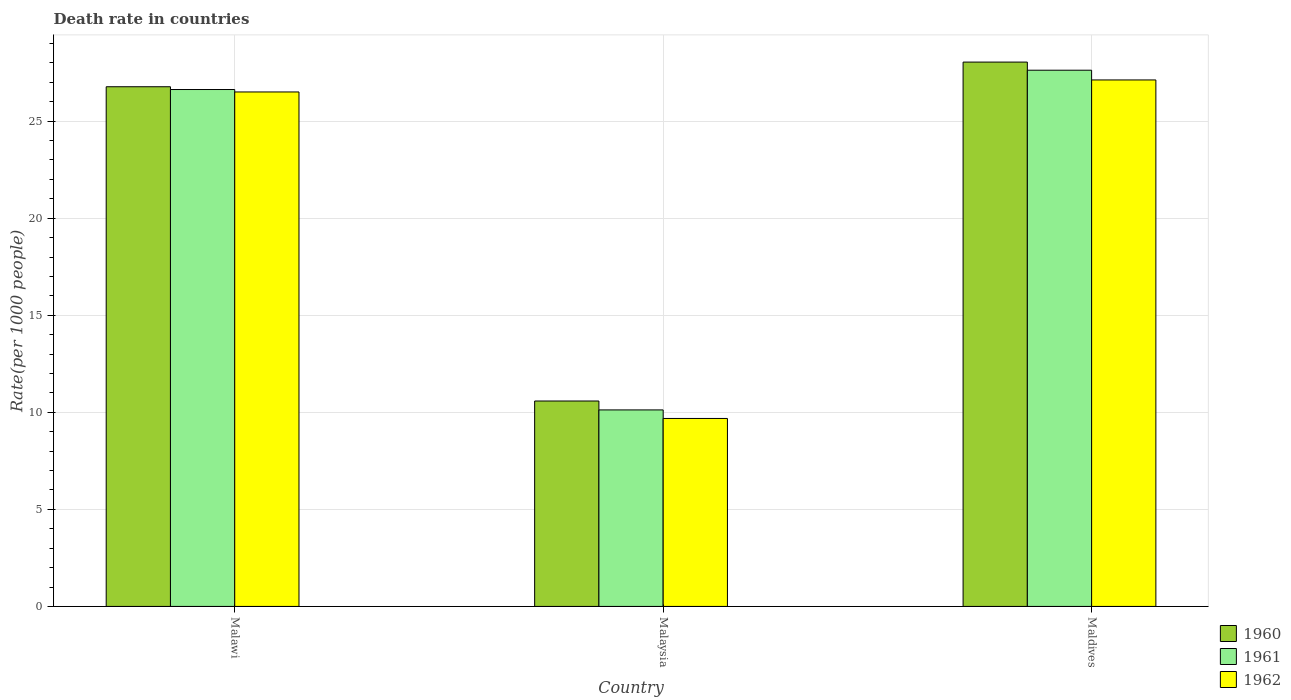How many groups of bars are there?
Your response must be concise. 3. Are the number of bars on each tick of the X-axis equal?
Your answer should be very brief. Yes. How many bars are there on the 3rd tick from the left?
Offer a terse response. 3. What is the label of the 2nd group of bars from the left?
Your response must be concise. Malaysia. What is the death rate in 1960 in Malaysia?
Provide a short and direct response. 10.58. Across all countries, what is the maximum death rate in 1962?
Your response must be concise. 27.12. Across all countries, what is the minimum death rate in 1962?
Ensure brevity in your answer.  9.68. In which country was the death rate in 1960 maximum?
Make the answer very short. Maldives. In which country was the death rate in 1962 minimum?
Keep it short and to the point. Malaysia. What is the total death rate in 1960 in the graph?
Ensure brevity in your answer.  65.39. What is the difference between the death rate in 1962 in Malawi and that in Malaysia?
Your answer should be very brief. 16.82. What is the difference between the death rate in 1962 in Maldives and the death rate in 1960 in Malawi?
Provide a succinct answer. 0.35. What is the average death rate in 1962 per country?
Make the answer very short. 21.1. What is the difference between the death rate of/in 1962 and death rate of/in 1961 in Malaysia?
Provide a short and direct response. -0.44. In how many countries, is the death rate in 1962 greater than 6?
Offer a terse response. 3. What is the ratio of the death rate in 1962 in Malawi to that in Malaysia?
Keep it short and to the point. 2.74. Is the death rate in 1961 in Malawi less than that in Maldives?
Your response must be concise. Yes. What is the difference between the highest and the second highest death rate in 1961?
Offer a terse response. -1. What is the difference between the highest and the lowest death rate in 1962?
Offer a very short reply. 17.44. What does the 3rd bar from the left in Malaysia represents?
Ensure brevity in your answer.  1962. Is it the case that in every country, the sum of the death rate in 1961 and death rate in 1960 is greater than the death rate in 1962?
Keep it short and to the point. Yes. Are the values on the major ticks of Y-axis written in scientific E-notation?
Provide a succinct answer. No. Does the graph contain grids?
Your answer should be very brief. Yes. How many legend labels are there?
Provide a short and direct response. 3. How are the legend labels stacked?
Make the answer very short. Vertical. What is the title of the graph?
Provide a succinct answer. Death rate in countries. What is the label or title of the X-axis?
Offer a terse response. Country. What is the label or title of the Y-axis?
Your answer should be very brief. Rate(per 1000 people). What is the Rate(per 1000 people) in 1960 in Malawi?
Ensure brevity in your answer.  26.77. What is the Rate(per 1000 people) in 1961 in Malawi?
Keep it short and to the point. 26.63. What is the Rate(per 1000 people) in 1962 in Malawi?
Provide a short and direct response. 26.5. What is the Rate(per 1000 people) of 1960 in Malaysia?
Offer a very short reply. 10.58. What is the Rate(per 1000 people) in 1961 in Malaysia?
Your answer should be very brief. 10.12. What is the Rate(per 1000 people) in 1962 in Malaysia?
Give a very brief answer. 9.68. What is the Rate(per 1000 people) of 1960 in Maldives?
Offer a very short reply. 28.04. What is the Rate(per 1000 people) of 1961 in Maldives?
Give a very brief answer. 27.62. What is the Rate(per 1000 people) of 1962 in Maldives?
Provide a succinct answer. 27.12. Across all countries, what is the maximum Rate(per 1000 people) in 1960?
Offer a very short reply. 28.04. Across all countries, what is the maximum Rate(per 1000 people) of 1961?
Offer a terse response. 27.62. Across all countries, what is the maximum Rate(per 1000 people) in 1962?
Your response must be concise. 27.12. Across all countries, what is the minimum Rate(per 1000 people) of 1960?
Your answer should be compact. 10.58. Across all countries, what is the minimum Rate(per 1000 people) of 1961?
Offer a terse response. 10.12. Across all countries, what is the minimum Rate(per 1000 people) in 1962?
Ensure brevity in your answer.  9.68. What is the total Rate(per 1000 people) of 1960 in the graph?
Your answer should be compact. 65.39. What is the total Rate(per 1000 people) of 1961 in the graph?
Ensure brevity in your answer.  64.37. What is the total Rate(per 1000 people) of 1962 in the graph?
Provide a short and direct response. 63.31. What is the difference between the Rate(per 1000 people) in 1960 in Malawi and that in Malaysia?
Provide a succinct answer. 16.19. What is the difference between the Rate(per 1000 people) of 1961 in Malawi and that in Malaysia?
Offer a terse response. 16.5. What is the difference between the Rate(per 1000 people) in 1962 in Malawi and that in Malaysia?
Ensure brevity in your answer.  16.82. What is the difference between the Rate(per 1000 people) of 1960 in Malawi and that in Maldives?
Provide a succinct answer. -1.27. What is the difference between the Rate(per 1000 people) of 1961 in Malawi and that in Maldives?
Your response must be concise. -0.99. What is the difference between the Rate(per 1000 people) in 1962 in Malawi and that in Maldives?
Provide a succinct answer. -0.62. What is the difference between the Rate(per 1000 people) of 1960 in Malaysia and that in Maldives?
Your response must be concise. -17.46. What is the difference between the Rate(per 1000 people) of 1961 in Malaysia and that in Maldives?
Offer a very short reply. -17.5. What is the difference between the Rate(per 1000 people) of 1962 in Malaysia and that in Maldives?
Your answer should be compact. -17.44. What is the difference between the Rate(per 1000 people) in 1960 in Malawi and the Rate(per 1000 people) in 1961 in Malaysia?
Provide a succinct answer. 16.65. What is the difference between the Rate(per 1000 people) of 1960 in Malawi and the Rate(per 1000 people) of 1962 in Malaysia?
Ensure brevity in your answer.  17.09. What is the difference between the Rate(per 1000 people) of 1961 in Malawi and the Rate(per 1000 people) of 1962 in Malaysia?
Offer a very short reply. 16.95. What is the difference between the Rate(per 1000 people) of 1960 in Malawi and the Rate(per 1000 people) of 1961 in Maldives?
Your answer should be compact. -0.85. What is the difference between the Rate(per 1000 people) of 1960 in Malawi and the Rate(per 1000 people) of 1962 in Maldives?
Your answer should be compact. -0.35. What is the difference between the Rate(per 1000 people) of 1961 in Malawi and the Rate(per 1000 people) of 1962 in Maldives?
Offer a very short reply. -0.49. What is the difference between the Rate(per 1000 people) of 1960 in Malaysia and the Rate(per 1000 people) of 1961 in Maldives?
Offer a very short reply. -17.04. What is the difference between the Rate(per 1000 people) in 1960 in Malaysia and the Rate(per 1000 people) in 1962 in Maldives?
Your answer should be very brief. -16.54. What is the difference between the Rate(per 1000 people) of 1961 in Malaysia and the Rate(per 1000 people) of 1962 in Maldives?
Give a very brief answer. -17. What is the average Rate(per 1000 people) in 1960 per country?
Your response must be concise. 21.8. What is the average Rate(per 1000 people) in 1961 per country?
Your answer should be compact. 21.46. What is the average Rate(per 1000 people) in 1962 per country?
Offer a terse response. 21.1. What is the difference between the Rate(per 1000 people) in 1960 and Rate(per 1000 people) in 1961 in Malawi?
Provide a short and direct response. 0.14. What is the difference between the Rate(per 1000 people) of 1960 and Rate(per 1000 people) of 1962 in Malawi?
Provide a short and direct response. 0.27. What is the difference between the Rate(per 1000 people) in 1961 and Rate(per 1000 people) in 1962 in Malawi?
Offer a very short reply. 0.13. What is the difference between the Rate(per 1000 people) in 1960 and Rate(per 1000 people) in 1961 in Malaysia?
Your answer should be compact. 0.46. What is the difference between the Rate(per 1000 people) of 1960 and Rate(per 1000 people) of 1962 in Malaysia?
Provide a succinct answer. 0.9. What is the difference between the Rate(per 1000 people) in 1961 and Rate(per 1000 people) in 1962 in Malaysia?
Keep it short and to the point. 0.44. What is the difference between the Rate(per 1000 people) in 1960 and Rate(per 1000 people) in 1961 in Maldives?
Provide a succinct answer. 0.42. What is the difference between the Rate(per 1000 people) of 1960 and Rate(per 1000 people) of 1962 in Maldives?
Offer a very short reply. 0.92. What is the difference between the Rate(per 1000 people) in 1961 and Rate(per 1000 people) in 1962 in Maldives?
Your answer should be very brief. 0.5. What is the ratio of the Rate(per 1000 people) of 1960 in Malawi to that in Malaysia?
Give a very brief answer. 2.53. What is the ratio of the Rate(per 1000 people) of 1961 in Malawi to that in Malaysia?
Your answer should be compact. 2.63. What is the ratio of the Rate(per 1000 people) of 1962 in Malawi to that in Malaysia?
Your answer should be compact. 2.74. What is the ratio of the Rate(per 1000 people) of 1960 in Malawi to that in Maldives?
Offer a very short reply. 0.95. What is the ratio of the Rate(per 1000 people) in 1961 in Malawi to that in Maldives?
Ensure brevity in your answer.  0.96. What is the ratio of the Rate(per 1000 people) of 1962 in Malawi to that in Maldives?
Make the answer very short. 0.98. What is the ratio of the Rate(per 1000 people) of 1960 in Malaysia to that in Maldives?
Your response must be concise. 0.38. What is the ratio of the Rate(per 1000 people) in 1961 in Malaysia to that in Maldives?
Give a very brief answer. 0.37. What is the ratio of the Rate(per 1000 people) in 1962 in Malaysia to that in Maldives?
Make the answer very short. 0.36. What is the difference between the highest and the second highest Rate(per 1000 people) in 1960?
Ensure brevity in your answer.  1.27. What is the difference between the highest and the second highest Rate(per 1000 people) of 1961?
Your response must be concise. 0.99. What is the difference between the highest and the second highest Rate(per 1000 people) of 1962?
Offer a terse response. 0.62. What is the difference between the highest and the lowest Rate(per 1000 people) of 1960?
Keep it short and to the point. 17.46. What is the difference between the highest and the lowest Rate(per 1000 people) of 1961?
Keep it short and to the point. 17.5. What is the difference between the highest and the lowest Rate(per 1000 people) of 1962?
Your answer should be very brief. 17.44. 